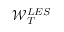Convert formula to latex. <formula><loc_0><loc_0><loc_500><loc_500>\mathcal { W } _ { T } ^ { L E S }</formula> 